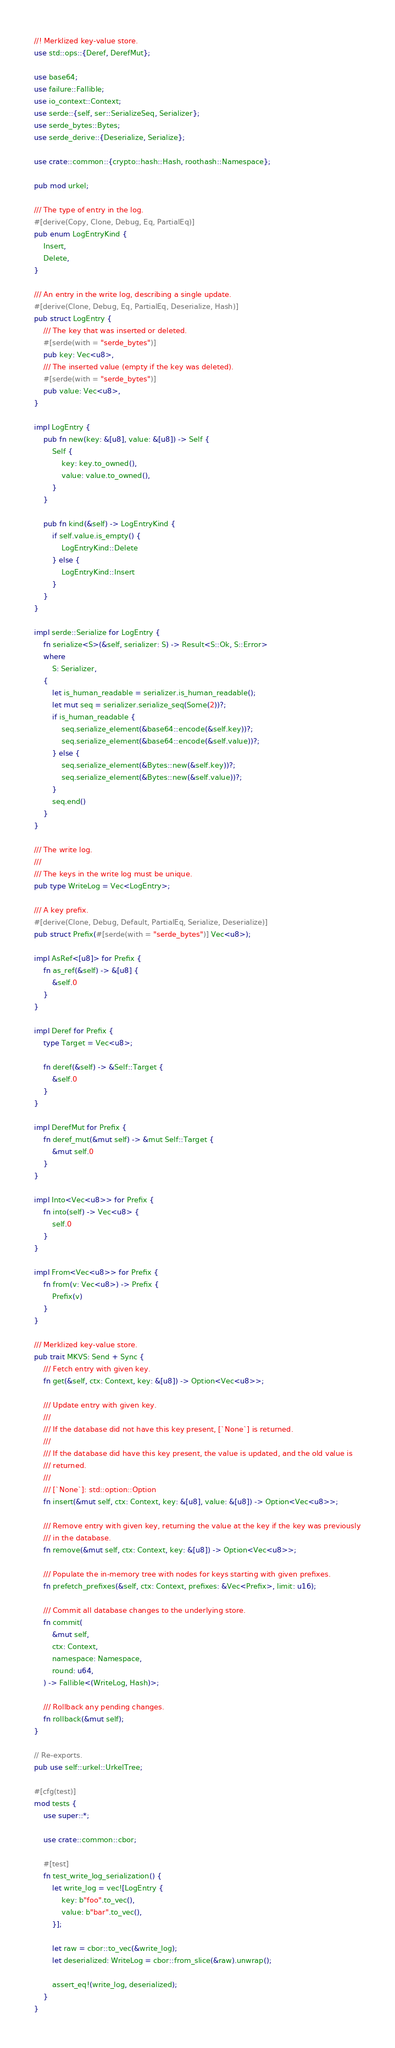Convert code to text. <code><loc_0><loc_0><loc_500><loc_500><_Rust_>//! Merklized key-value store.
use std::ops::{Deref, DerefMut};

use base64;
use failure::Fallible;
use io_context::Context;
use serde::{self, ser::SerializeSeq, Serializer};
use serde_bytes::Bytes;
use serde_derive::{Deserialize, Serialize};

use crate::common::{crypto::hash::Hash, roothash::Namespace};

pub mod urkel;

/// The type of entry in the log.
#[derive(Copy, Clone, Debug, Eq, PartialEq)]
pub enum LogEntryKind {
    Insert,
    Delete,
}

/// An entry in the write log, describing a single update.
#[derive(Clone, Debug, Eq, PartialEq, Deserialize, Hash)]
pub struct LogEntry {
    /// The key that was inserted or deleted.
    #[serde(with = "serde_bytes")]
    pub key: Vec<u8>,
    /// The inserted value (empty if the key was deleted).
    #[serde(with = "serde_bytes")]
    pub value: Vec<u8>,
}

impl LogEntry {
    pub fn new(key: &[u8], value: &[u8]) -> Self {
        Self {
            key: key.to_owned(),
            value: value.to_owned(),
        }
    }

    pub fn kind(&self) -> LogEntryKind {
        if self.value.is_empty() {
            LogEntryKind::Delete
        } else {
            LogEntryKind::Insert
        }
    }
}

impl serde::Serialize for LogEntry {
    fn serialize<S>(&self, serializer: S) -> Result<S::Ok, S::Error>
    where
        S: Serializer,
    {
        let is_human_readable = serializer.is_human_readable();
        let mut seq = serializer.serialize_seq(Some(2))?;
        if is_human_readable {
            seq.serialize_element(&base64::encode(&self.key))?;
            seq.serialize_element(&base64::encode(&self.value))?;
        } else {
            seq.serialize_element(&Bytes::new(&self.key))?;
            seq.serialize_element(&Bytes::new(&self.value))?;
        }
        seq.end()
    }
}

/// The write log.
///
/// The keys in the write log must be unique.
pub type WriteLog = Vec<LogEntry>;

/// A key prefix.
#[derive(Clone, Debug, Default, PartialEq, Serialize, Deserialize)]
pub struct Prefix(#[serde(with = "serde_bytes")] Vec<u8>);

impl AsRef<[u8]> for Prefix {
    fn as_ref(&self) -> &[u8] {
        &self.0
    }
}

impl Deref for Prefix {
    type Target = Vec<u8>;

    fn deref(&self) -> &Self::Target {
        &self.0
    }
}

impl DerefMut for Prefix {
    fn deref_mut(&mut self) -> &mut Self::Target {
        &mut self.0
    }
}

impl Into<Vec<u8>> for Prefix {
    fn into(self) -> Vec<u8> {
        self.0
    }
}

impl From<Vec<u8>> for Prefix {
    fn from(v: Vec<u8>) -> Prefix {
        Prefix(v)
    }
}

/// Merklized key-value store.
pub trait MKVS: Send + Sync {
    /// Fetch entry with given key.
    fn get(&self, ctx: Context, key: &[u8]) -> Option<Vec<u8>>;

    /// Update entry with given key.
    ///
    /// If the database did not have this key present, [`None`] is returned.
    ///
    /// If the database did have this key present, the value is updated, and the old value is
    /// returned.
    ///
    /// [`None`]: std::option::Option
    fn insert(&mut self, ctx: Context, key: &[u8], value: &[u8]) -> Option<Vec<u8>>;

    /// Remove entry with given key, returning the value at the key if the key was previously
    /// in the database.
    fn remove(&mut self, ctx: Context, key: &[u8]) -> Option<Vec<u8>>;

    /// Populate the in-memory tree with nodes for keys starting with given prefixes.
    fn prefetch_prefixes(&self, ctx: Context, prefixes: &Vec<Prefix>, limit: u16);

    /// Commit all database changes to the underlying store.
    fn commit(
        &mut self,
        ctx: Context,
        namespace: Namespace,
        round: u64,
    ) -> Fallible<(WriteLog, Hash)>;

    /// Rollback any pending changes.
    fn rollback(&mut self);
}

// Re-exports.
pub use self::urkel::UrkelTree;

#[cfg(test)]
mod tests {
    use super::*;

    use crate::common::cbor;

    #[test]
    fn test_write_log_serialization() {
        let write_log = vec![LogEntry {
            key: b"foo".to_vec(),
            value: b"bar".to_vec(),
        }];

        let raw = cbor::to_vec(&write_log);
        let deserialized: WriteLog = cbor::from_slice(&raw).unwrap();

        assert_eq!(write_log, deserialized);
    }
}
</code> 